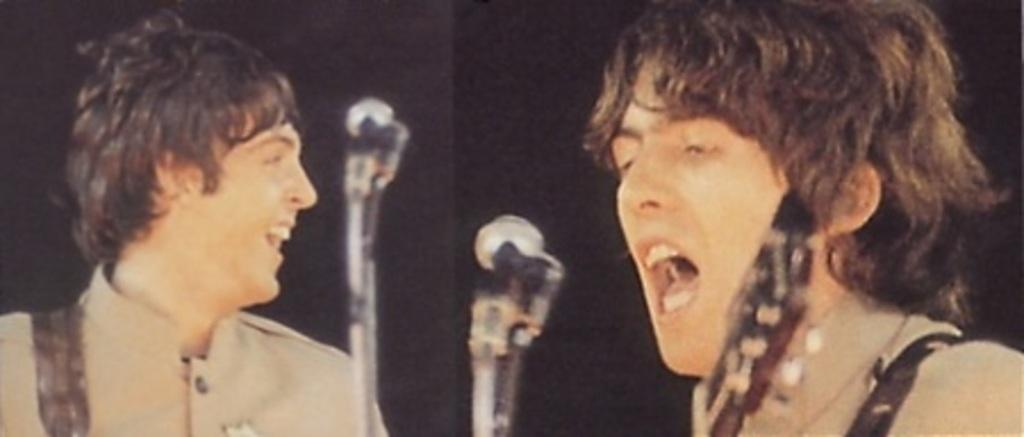What is the person in the image holding? The person is holding a guitar in the image. What other object can be seen in the image? There is a microphone (mic) in the image. How many people are in the image? There are two people in the image. What is the second person holding? The second person is also holding a microphone. How many quarters can be seen in the image? There are no quarters present in the image. Is there a wheel visible in the image? There is no wheel visible in the image. 